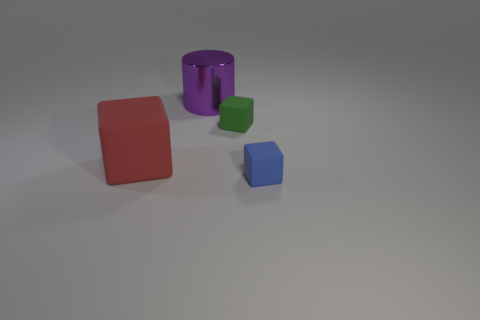There is a metallic object; is it the same size as the thing on the left side of the shiny object?
Your answer should be compact. Yes. What number of small rubber cubes have the same color as the big metal cylinder?
Your response must be concise. 0. How many things are either tiny yellow matte cylinders or cubes behind the large cube?
Offer a very short reply. 1. There is a rubber thing in front of the red object; is it the same size as the block left of the cylinder?
Offer a very short reply. No. Is there another cube that has the same material as the large red cube?
Ensure brevity in your answer.  Yes. The large purple metal thing has what shape?
Your response must be concise. Cylinder. There is a tiny object that is in front of the small thing that is behind the tiny blue rubber cube; what is its shape?
Ensure brevity in your answer.  Cube. What number of other objects are the same shape as the small green matte object?
Ensure brevity in your answer.  2. There is a cube that is on the left side of the tiny rubber thing that is behind the blue rubber block; what is its size?
Your answer should be compact. Large. Are there any brown matte things?
Make the answer very short. No. 